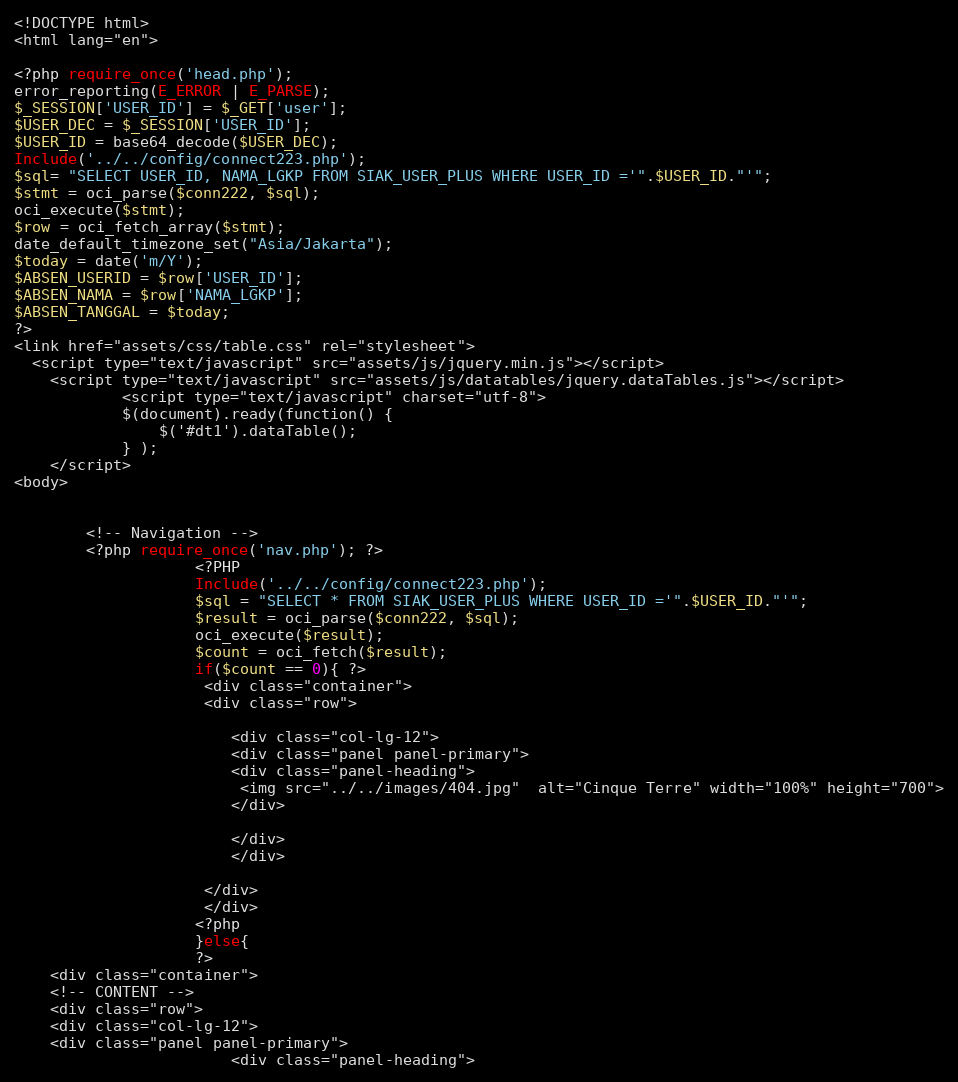<code> <loc_0><loc_0><loc_500><loc_500><_PHP_><!DOCTYPE html>
<html lang="en">

<?php require_once('head.php'); 
error_reporting(E_ERROR | E_PARSE);
$_SESSION['USER_ID'] = $_GET['user'];
$USER_DEC = $_SESSION['USER_ID'];
$USER_ID = base64_decode($USER_DEC);
Include('../../config/connect223.php');
$sql= "SELECT USER_ID, NAMA_LGKP FROM SIAK_USER_PLUS WHERE USER_ID ='".$USER_ID."'";
$stmt = oci_parse($conn222, $sql);
oci_execute($stmt);
$row = oci_fetch_array($stmt);
date_default_timezone_set("Asia/Jakarta");
$today = date('m/Y');
$ABSEN_USERID = $row['USER_ID'];
$ABSEN_NAMA = $row['NAMA_LGKP'];
$ABSEN_TANGGAL = $today;
?> 
<link href="assets/css/table.css" rel="stylesheet">
  <script type="text/javascript" src="assets/js/jquery.min.js"></script>
    <script type="text/javascript" src="assets/js/datatables/jquery.dataTables.js"></script>
  			<script type="text/javascript" charset="utf-8">
			$(document).ready(function() {
				$('#dt1').dataTable();
			} );
	</script>
<body>
   

        <!-- Navigation -->
        <?php require_once('nav.php'); ?> 
					<?PHP		
					Include('../../config/connect223.php');
					$sql = "SELECT * FROM SIAK_USER_PLUS WHERE USER_ID ='".$USER_ID."'";
					$result = oci_parse($conn222, $sql);
					oci_execute($result);
					$count = oci_fetch($result);
					if($count == 0){ ?>
					 <div class="container">
					 <div class="row">
						
						<div class="col-lg-12">
						<div class="panel panel-primary">
                        <div class="panel-heading">
                         <img src="../../images/404.jpg"  alt="Cinque Terre" width="100%" height="700">
                        </div>
                        
						</div>
						</div>
		
					 </div>
					 </div>
					<?php
					}else{
					?>
	<div class="container">
	<!-- CONTENT -->
	<div class="row">
	<div class="col-lg-12">
	<div class="panel panel-primary">
                        <div class="panel-heading"></code> 